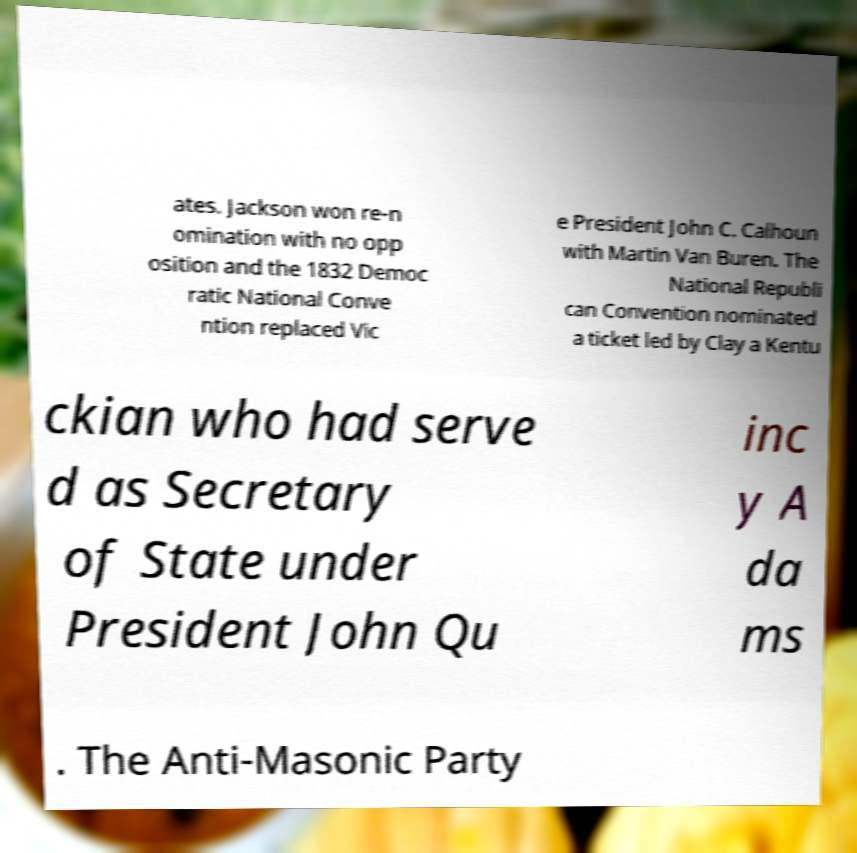For documentation purposes, I need the text within this image transcribed. Could you provide that? ates. Jackson won re-n omination with no opp osition and the 1832 Democ ratic National Conve ntion replaced Vic e President John C. Calhoun with Martin Van Buren. The National Republi can Convention nominated a ticket led by Clay a Kentu ckian who had serve d as Secretary of State under President John Qu inc y A da ms . The Anti-Masonic Party 